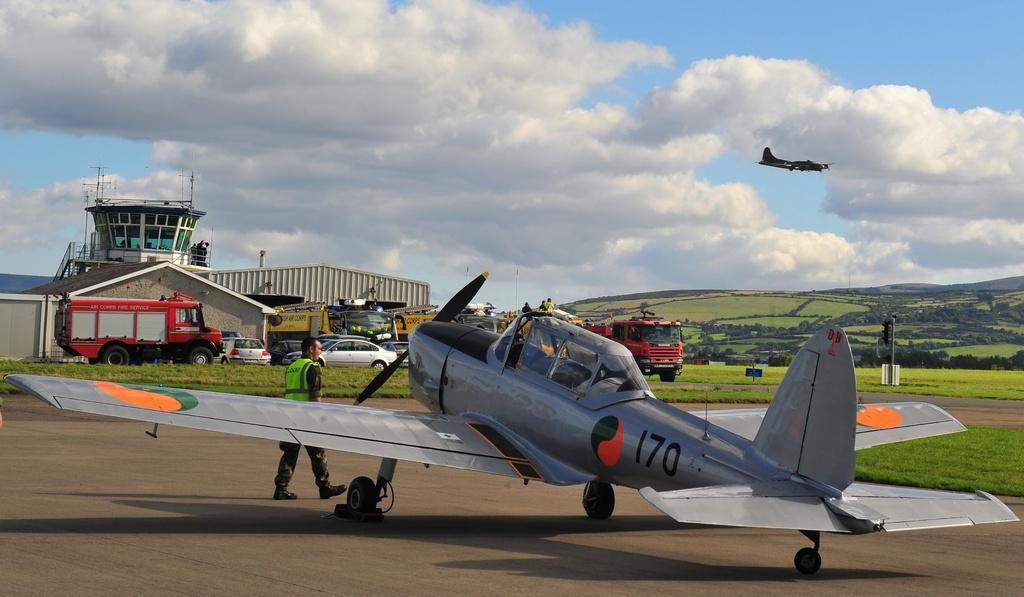What is the tail number of this airplane?
Your answer should be very brief. 170. What number is written on the bottom half of the plane?
Ensure brevity in your answer.  170. 